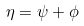<formula> <loc_0><loc_0><loc_500><loc_500>\eta = \psi + \phi</formula> 